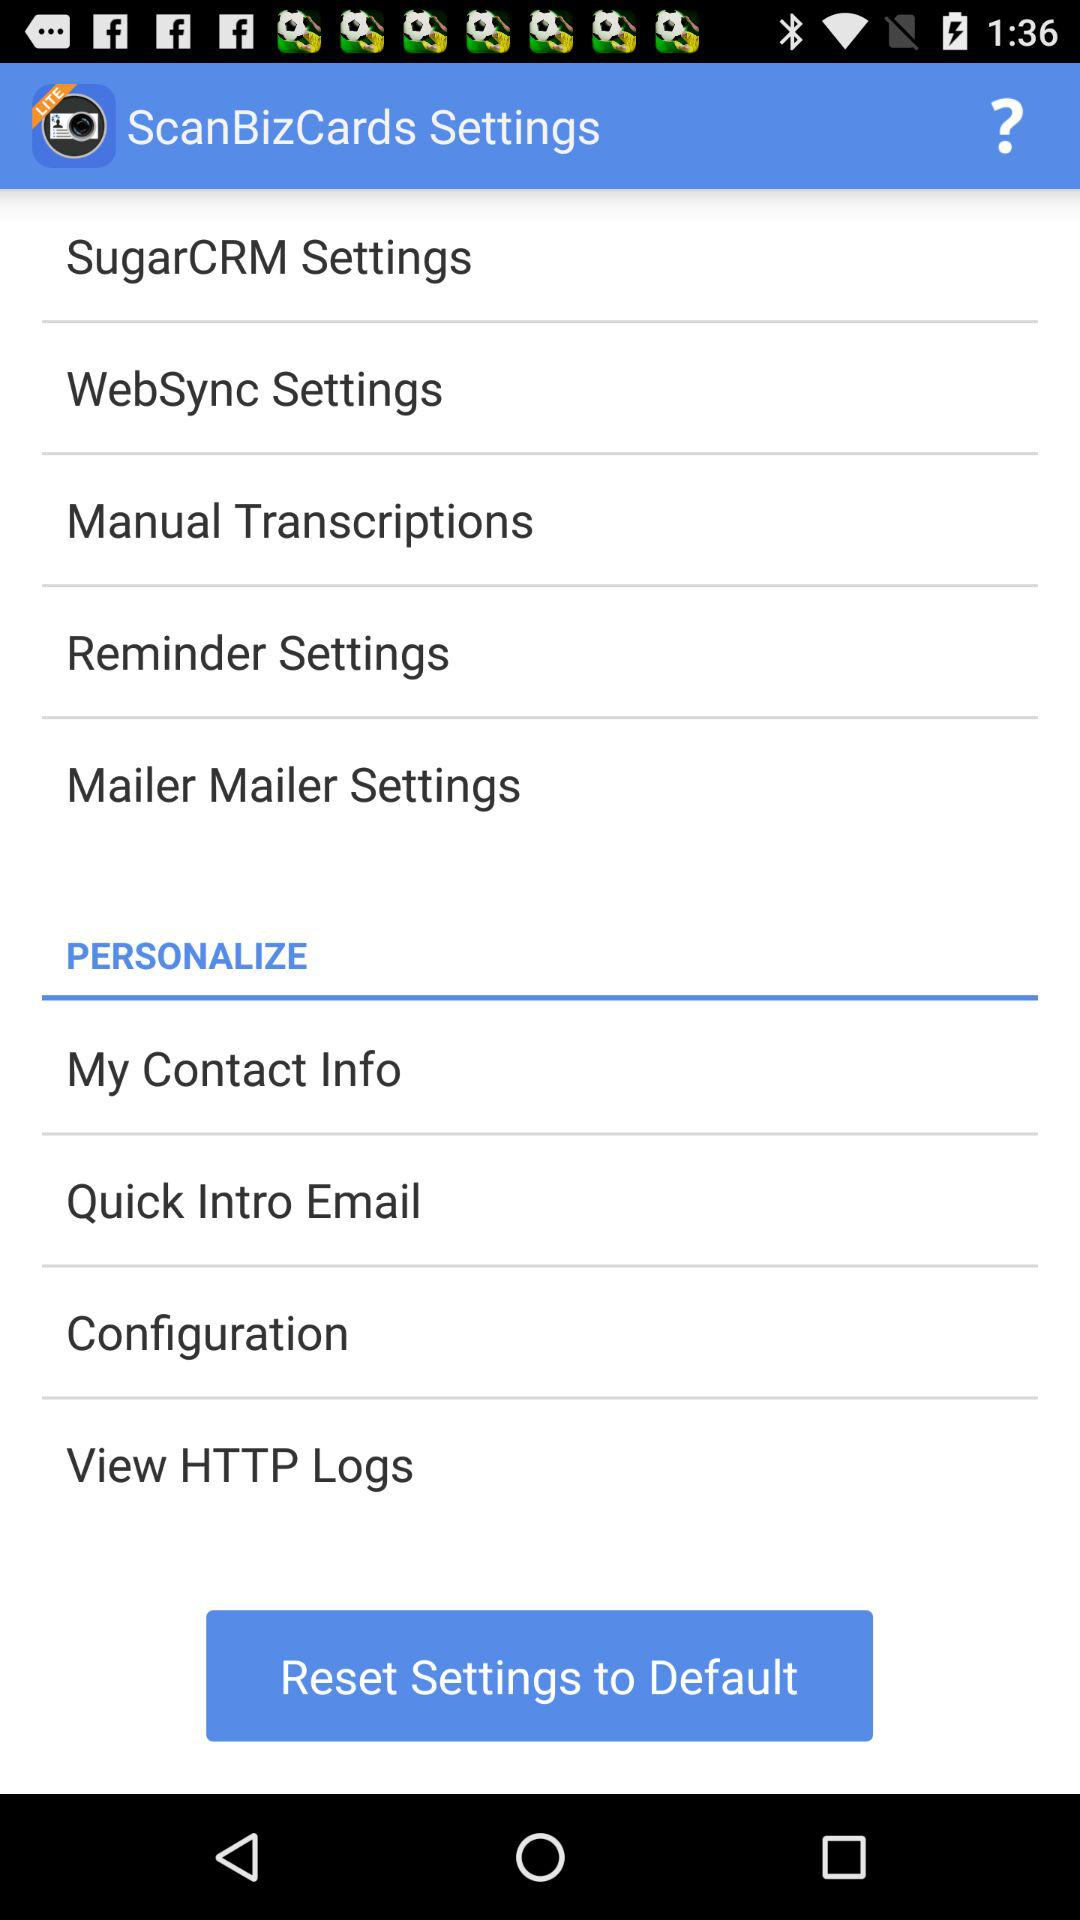What is the application name? The application name is "ScanBizCards Lite - Business C". 